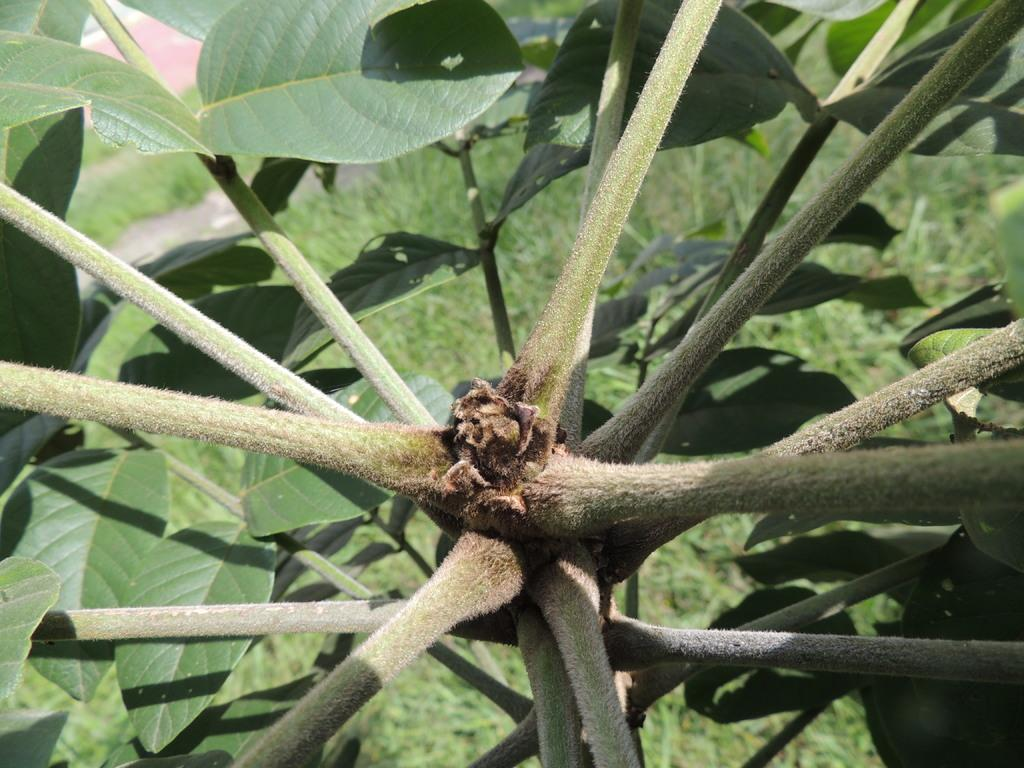What type of plant is visible in the image? There is a plant with leaves in the image. What can be seen on the ground in the image? There is grass on the ground in the image. What type of pancake is being served on the truck in the image? There is no truck or pancake present in the image; it only features a plant with leaves and grass on the ground. 